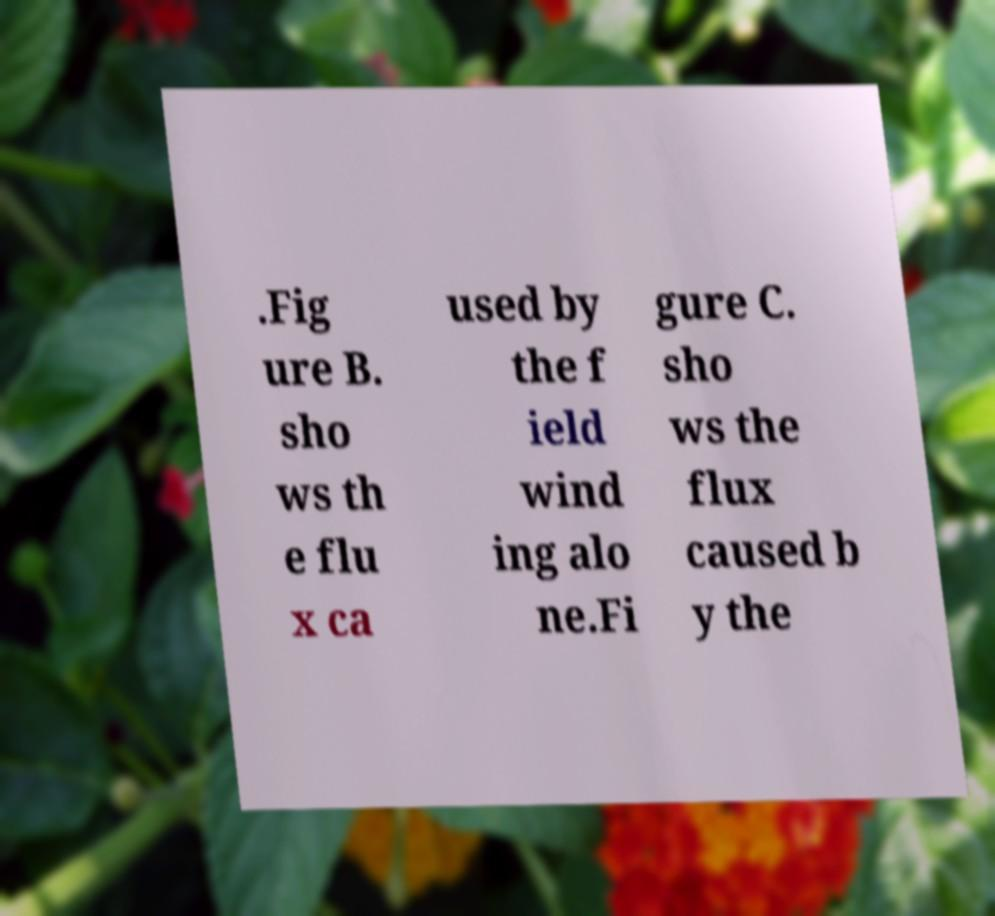There's text embedded in this image that I need extracted. Can you transcribe it verbatim? .Fig ure B. sho ws th e flu x ca used by the f ield wind ing alo ne.Fi gure C. sho ws the flux caused b y the 